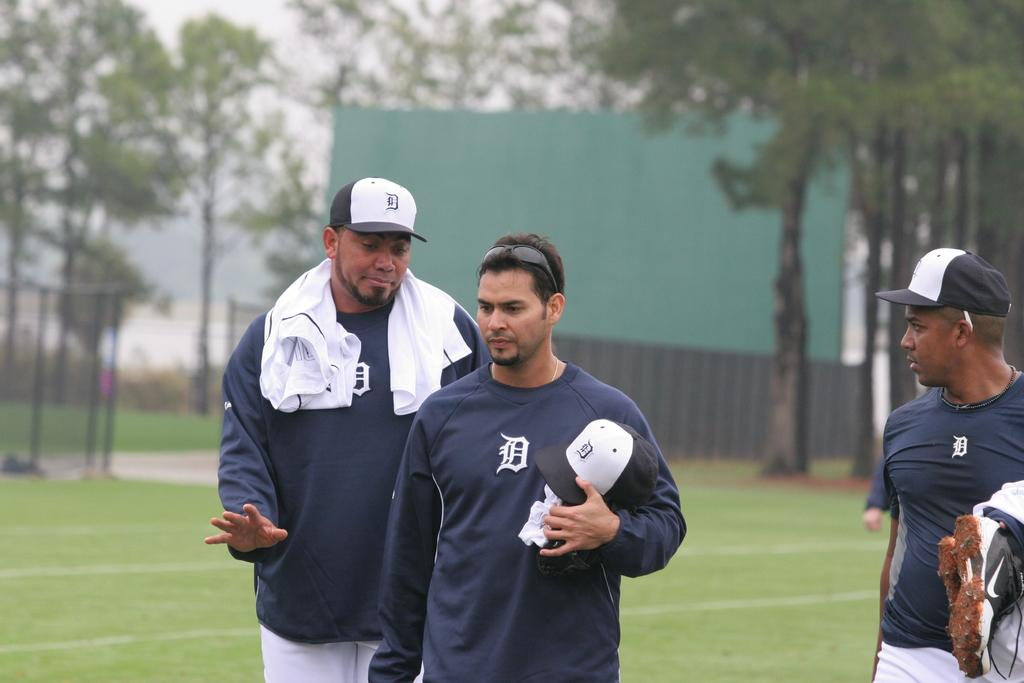What are the people in the image doing? The people in the image are standing in the middle of the image. What type of terrain is visible in the image? There is grass visible in the image. What type of vegetation can be seen in the image? There are trees in the image. What invention can be seen in the hands of the people in the image? There is no invention visible in the hands of the people in the image. What type of paper is being used by the people in the image? There is no paper present in the image. 